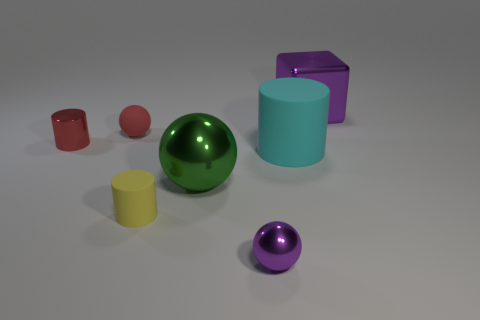Which object appears to have the smoothest surface? The green spherical object in the center appears to have the smoothest surface, reflecting light uniformly with a glossy finish. 